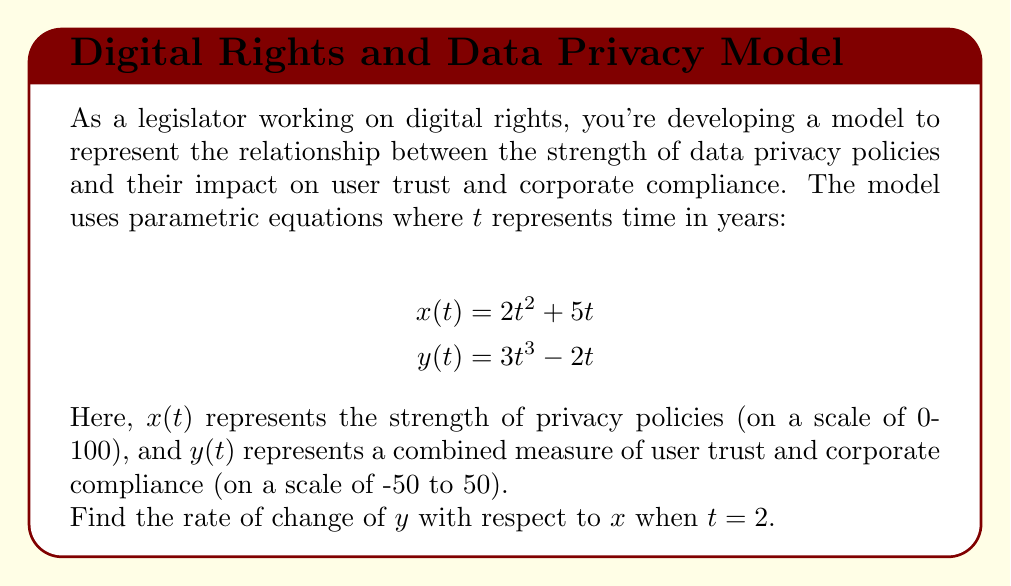Can you answer this question? To solve this problem, we need to use the chain rule for parametric equations. The rate of change of $y$ with respect to $x$ is given by:

$$\frac{dy}{dx} = \frac{dy/dt}{dx/dt}$$

Let's follow these steps:

1) First, we need to find $dx/dt$ and $dy/dt$:

   $$\frac{dx}{dt} = \frac{d}{dt}(2t^2 + 5t) = 4t + 5$$
   $$\frac{dy}{dt} = \frac{d}{dt}(3t^3 - 2t) = 9t^2 - 2$$

2) Now, we can set up our equation for $dy/dx$:

   $$\frac{dy}{dx} = \frac{9t^2 - 2}{4t + 5}$$

3) We need to evaluate this at $t = 2$:

   $$\frac{dy}{dx}\bigg|_{t=2} = \frac{9(2)^2 - 2}{4(2) + 5} = \frac{34}{13}$$

Therefore, when $t = 2$, the rate of change of $y$ with respect to $x$ is $\frac{34}{13}$.
Answer: $\frac{34}{13}$ 